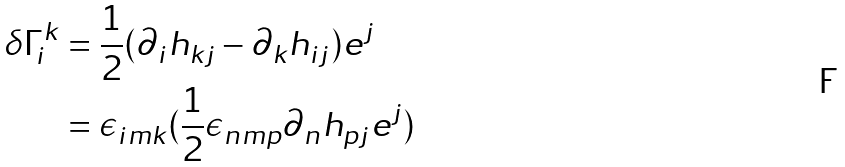Convert formula to latex. <formula><loc_0><loc_0><loc_500><loc_500>\delta \Gamma ^ { k } _ { i } & = \frac { 1 } { 2 } ( \partial _ { i } h _ { k j } - \partial _ { k } h _ { i j } ) e ^ { j } \\ & = \epsilon _ { i m k } ( \frac { 1 } { 2 } \epsilon _ { n m p } \partial _ { n } h _ { p j } e ^ { j } )</formula> 